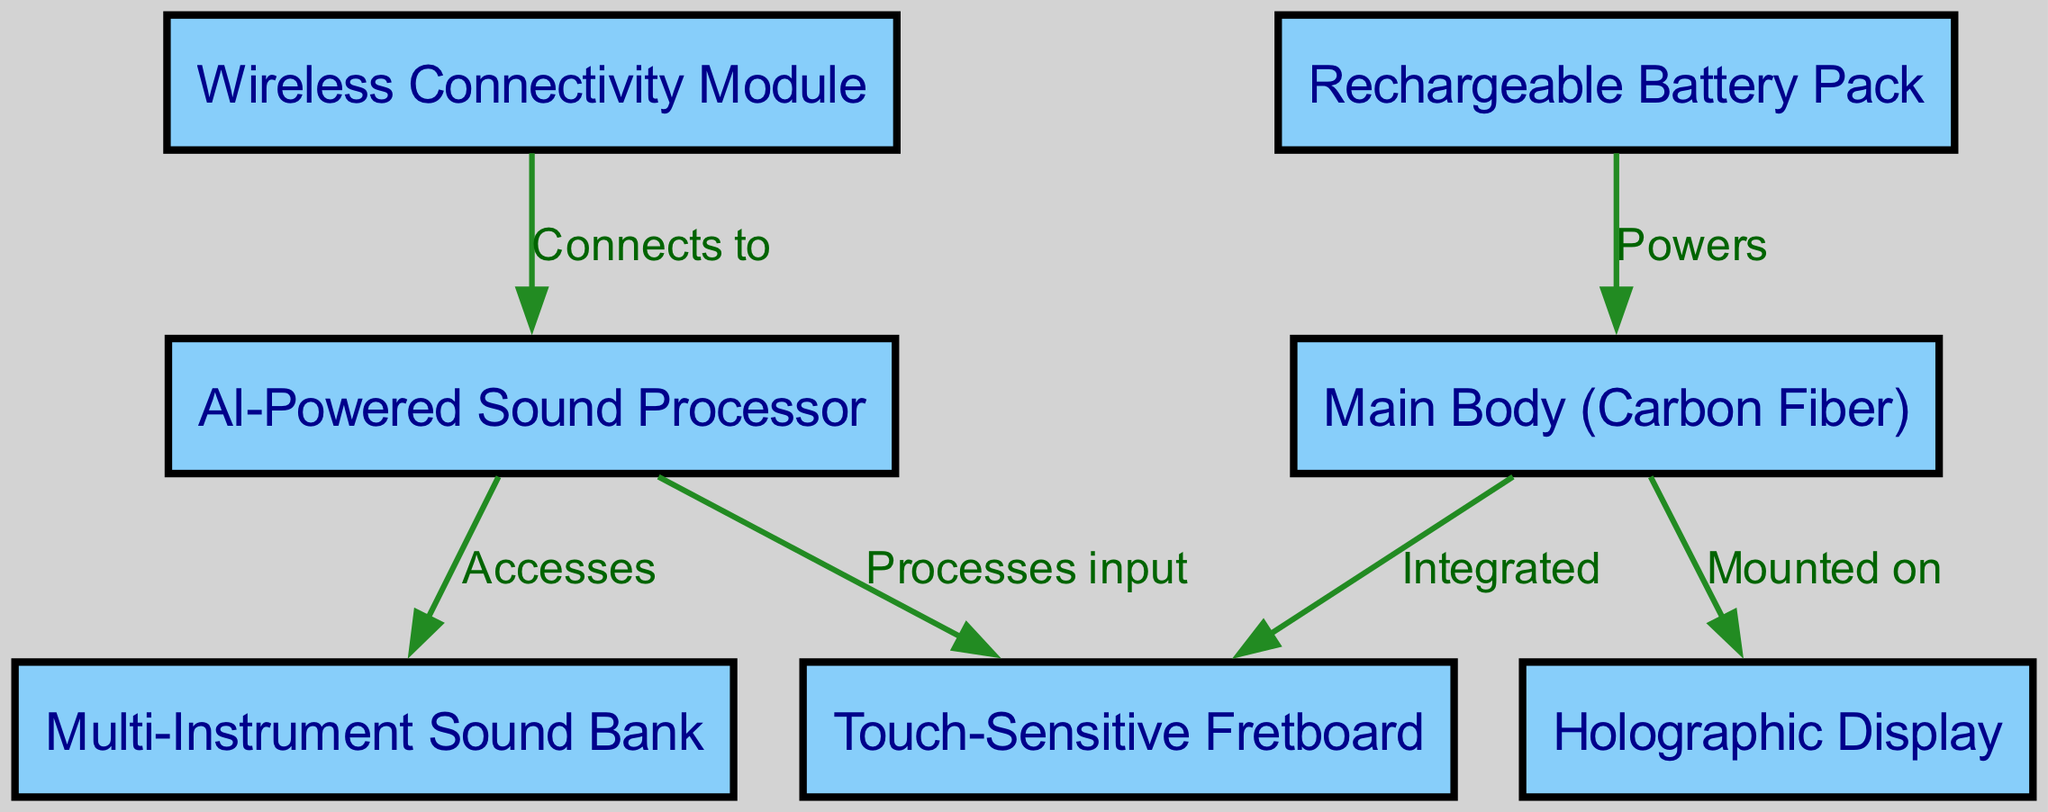What is the primary material of the main body? The diagram specifies that the "Main Body" is made of "Carbon Fiber." This is clearly labeled in the relevant node.
Answer: Carbon Fiber How many nodes are present in the diagram? Counting each labeled box, there are seven distinct nodes representing various components of the custom-made musical instrument.
Answer: 7 What connects to the AI-Powered Sound Processor? The edges indicate that both the "Touch-Sensitive Fretboard" (processes input) and "Multi-Instrument Sound Bank" (accesses) are connected to the "AI-Powered Sound Processor," indicating they interact with it.
Answer: Touch-Sensitive Fretboard, Multi-Instrument Sound Bank What powers the Main Body? The diagram shows that the "Rechargeable Battery Pack" powers the "Main Body," as specified in the edge relation labeled "Powers."
Answer: Rechargeable Battery Pack What is mounted on the Main Body? According to the diagram, the "Holographic Display" is specifically labeled as "Mounted on" the "Main Body," which identifies its location and function.
Answer: Holographic Display What component connects to the Wireless Connectivity Module? The diagram indicates that the "AI-Powered Sound Processor" connects to the "Wireless Connectivity Module," establishing a direct link between the two components.
Answer: AI-Powered Sound Processor Which component has integrated features with the Main Body? The "Touch-Sensitive Fretboard" is clearly labeled as being "Integrated" with the "Main Body," establishing their close relationship in functionality.
Answer: Touch-Sensitive Fretboard Which feature processes input from the Touch-Sensitive Fretboard? The "AI-Powered Sound Processor" is noted in the diagram as processing input from the "Touch-Sensitive Fretboard," indicating its role in managing the signals received from it.
Answer: AI-Powered Sound Processor 